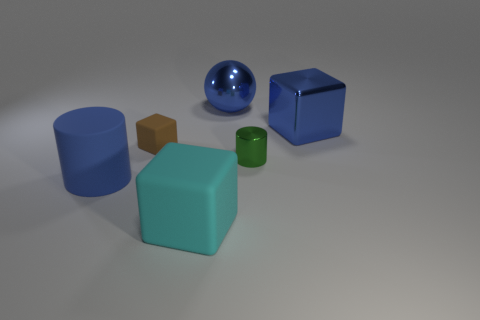Are there fewer tiny gray metal cubes than tiny metal things?
Ensure brevity in your answer.  Yes. The cylinder to the right of the object that is in front of the blue cylinder is what color?
Ensure brevity in your answer.  Green. There is a small object on the left side of the thing that is behind the blue thing right of the tiny metallic object; what is its material?
Make the answer very short. Rubber. Do the cylinder left of the green cylinder and the blue sphere have the same size?
Keep it short and to the point. Yes. What is the material of the blue thing left of the tiny brown matte block?
Make the answer very short. Rubber. Is the number of red cylinders greater than the number of big metal spheres?
Offer a very short reply. No. What number of objects are large blue objects that are on the left side of the small green metallic thing or big cyan metallic things?
Offer a terse response. 2. How many rubber cubes are on the right side of the cube that is in front of the small brown rubber object?
Offer a very short reply. 0. There is a blue shiny thing that is in front of the large sphere left of the blue metal object right of the ball; what size is it?
Make the answer very short. Large. There is a tiny object behind the metal cylinder; is its color the same as the metal cylinder?
Your answer should be very brief. No. 